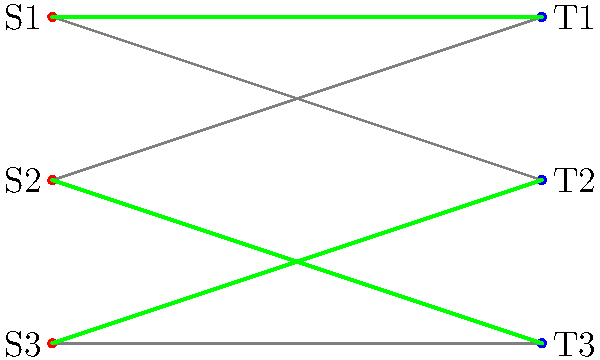In a hospital ward, there are three staff members (S1, S2, S3) and three time slots (T1, T2, T3) for patient care. To minimize infection risk, each staff member can only work in certain time slots based on their exposure history. The bipartite graph shows the possible assignments, with green edges representing the optimal matching. What is the maximum number of staff-time slot pairs that can be assigned while ensuring each staff member and time slot is used only once? To solve this problem, we'll use the concept of maximum matching in a bipartite graph:

1. Identify the bipartite graph:
   - Set S: Staff members (S1, S2, S3)
   - Set T: Time slots (T1, T2, T3)

2. Analyze the edges:
   - S1 can work in T1 and T2
   - S2 can work in T1 and T3
   - S3 can work in T2 and T3

3. Find the maximum matching:
   - A matching is a set of edges where no two edges share a vertex
   - The maximum matching is the largest possible set of such edges

4. Identify the maximum matching (green edges):
   - S1 -- T1
   - S2 -- T3
   - S3 -- T2

5. Count the edges in the maximum matching:
   - There are 3 edges in the maximum matching

6. Interpret the result:
   - This means we can assign all 3 staff members to different time slots
   - Each staff member is used once, and each time slot is filled once
   - This minimizes infection risk by optimizing the rotation schedule

The maximum number of staff-time slot pairs that can be assigned is 3, which is the number of edges in the maximum matching.
Answer: 3 